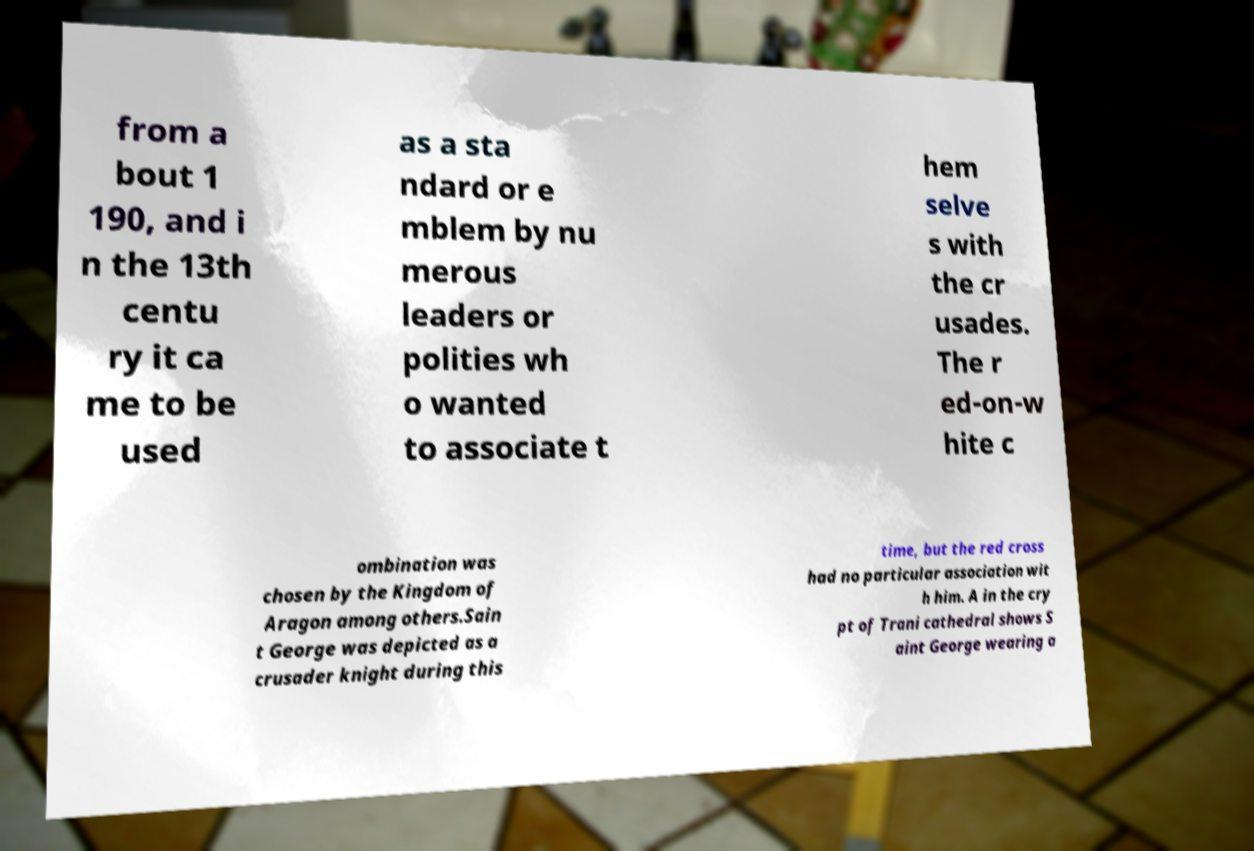Please read and relay the text visible in this image. What does it say? from a bout 1 190, and i n the 13th centu ry it ca me to be used as a sta ndard or e mblem by nu merous leaders or polities wh o wanted to associate t hem selve s with the cr usades. The r ed-on-w hite c ombination was chosen by the Kingdom of Aragon among others.Sain t George was depicted as a crusader knight during this time, but the red cross had no particular association wit h him. A in the cry pt of Trani cathedral shows S aint George wearing a 